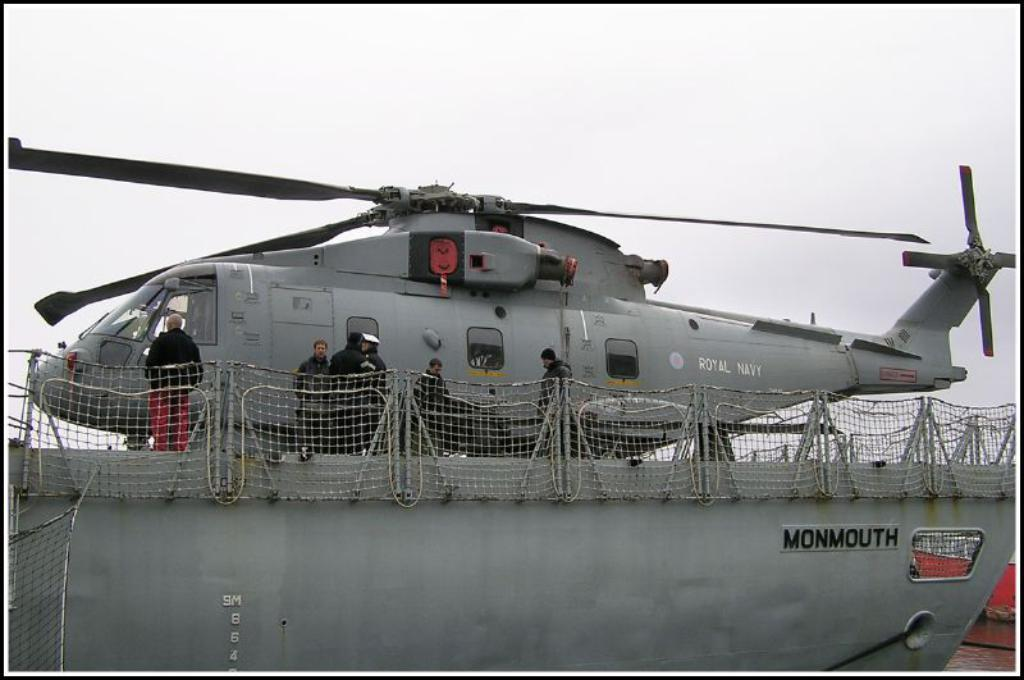<image>
Provide a brief description of the given image. Royal Navy Helicopter that is landed on a ship. 